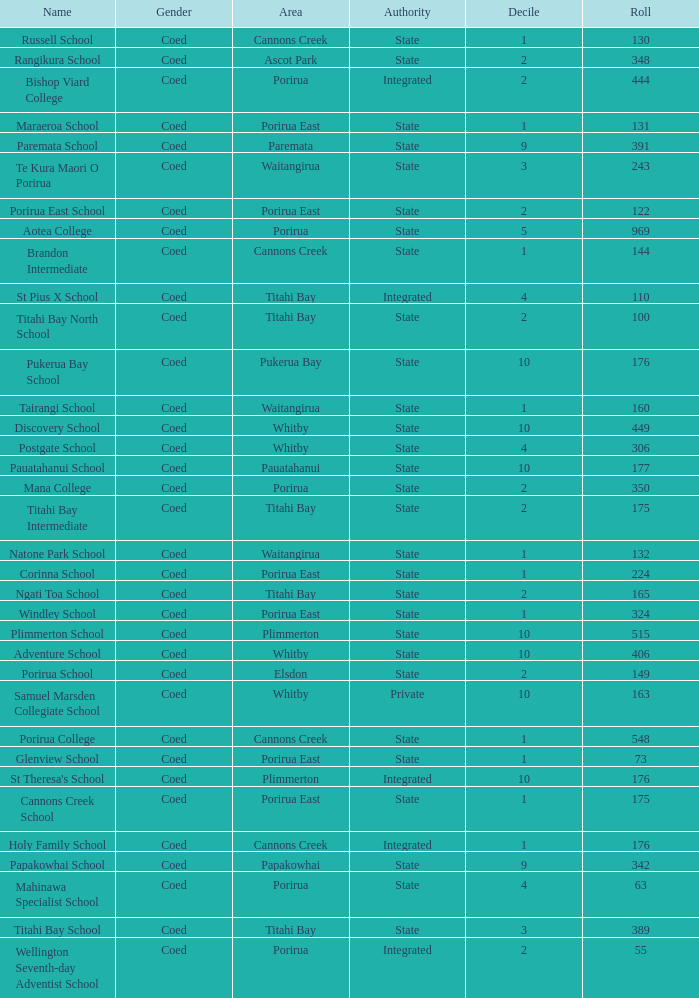Give me the full table as a dictionary. {'header': ['Name', 'Gender', 'Area', 'Authority', 'Decile', 'Roll'], 'rows': [['Russell School', 'Coed', 'Cannons Creek', 'State', '1', '130'], ['Rangikura School', 'Coed', 'Ascot Park', 'State', '2', '348'], ['Bishop Viard College', 'Coed', 'Porirua', 'Integrated', '2', '444'], ['Maraeroa School', 'Coed', 'Porirua East', 'State', '1', '131'], ['Paremata School', 'Coed', 'Paremata', 'State', '9', '391'], ['Te Kura Maori O Porirua', 'Coed', 'Waitangirua', 'State', '3', '243'], ['Porirua East School', 'Coed', 'Porirua East', 'State', '2', '122'], ['Aotea College', 'Coed', 'Porirua', 'State', '5', '969'], ['Brandon Intermediate', 'Coed', 'Cannons Creek', 'State', '1', '144'], ['St Pius X School', 'Coed', 'Titahi Bay', 'Integrated', '4', '110'], ['Titahi Bay North School', 'Coed', 'Titahi Bay', 'State', '2', '100'], ['Pukerua Bay School', 'Coed', 'Pukerua Bay', 'State', '10', '176'], ['Tairangi School', 'Coed', 'Waitangirua', 'State', '1', '160'], ['Discovery School', 'Coed', 'Whitby', 'State', '10', '449'], ['Postgate School', 'Coed', 'Whitby', 'State', '4', '306'], ['Pauatahanui School', 'Coed', 'Pauatahanui', 'State', '10', '177'], ['Mana College', 'Coed', 'Porirua', 'State', '2', '350'], ['Titahi Bay Intermediate', 'Coed', 'Titahi Bay', 'State', '2', '175'], ['Natone Park School', 'Coed', 'Waitangirua', 'State', '1', '132'], ['Corinna School', 'Coed', 'Porirua East', 'State', '1', '224'], ['Ngati Toa School', 'Coed', 'Titahi Bay', 'State', '2', '165'], ['Windley School', 'Coed', 'Porirua East', 'State', '1', '324'], ['Plimmerton School', 'Coed', 'Plimmerton', 'State', '10', '515'], ['Adventure School', 'Coed', 'Whitby', 'State', '10', '406'], ['Porirua School', 'Coed', 'Elsdon', 'State', '2', '149'], ['Samuel Marsden Collegiate School', 'Coed', 'Whitby', 'Private', '10', '163'], ['Porirua College', 'Coed', 'Cannons Creek', 'State', '1', '548'], ['Glenview School', 'Coed', 'Porirua East', 'State', '1', '73'], ["St Theresa's School", 'Coed', 'Plimmerton', 'Integrated', '10', '176'], ['Cannons Creek School', 'Coed', 'Porirua East', 'State', '1', '175'], ['Holy Family School', 'Coed', 'Cannons Creek', 'Integrated', '1', '176'], ['Papakowhai School', 'Coed', 'Papakowhai', 'State', '9', '342'], ['Mahinawa Specialist School', 'Coed', 'Porirua', 'State', '4', '63'], ['Titahi Bay School', 'Coed', 'Titahi Bay', 'State', '3', '389'], ['Wellington Seventh-day Adventist School', 'Coed', 'Porirua', 'Integrated', '2', '55']]} What was the decile of Samuel Marsden Collegiate School in Whitby, when it had a roll higher than 163? 0.0. 